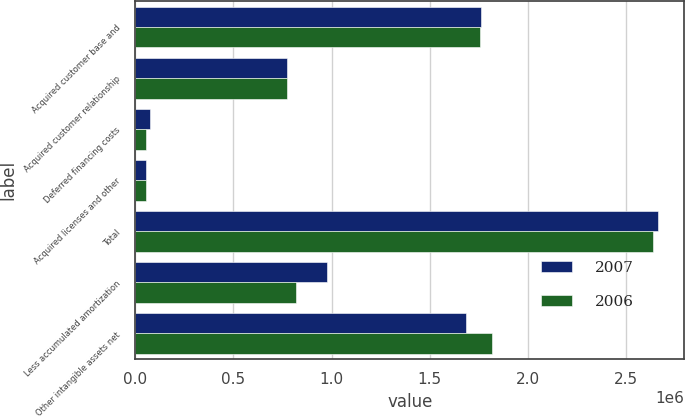Convert chart. <chart><loc_0><loc_0><loc_500><loc_500><stacked_bar_chart><ecel><fcel>Acquired customer base and<fcel>Acquired customer relationship<fcel>Deferred financing costs<fcel>Acquired licenses and other<fcel>Total<fcel>Less accumulated amortization<fcel>Other intangible assets net<nl><fcel>2007<fcel>1.76071e+06<fcel>775000<fcel>75934<fcel>53866<fcel>2.66551e+06<fcel>979073<fcel>1.68643e+06<nl><fcel>2006<fcel>1.7552e+06<fcel>775000<fcel>56084<fcel>51703<fcel>2.63799e+06<fcel>817112<fcel>1.82088e+06<nl></chart> 